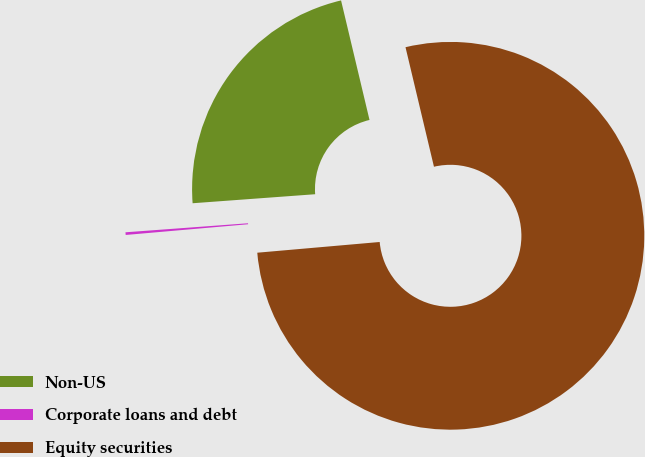<chart> <loc_0><loc_0><loc_500><loc_500><pie_chart><fcel>Non-US<fcel>Corporate loans and debt<fcel>Equity securities<nl><fcel>22.45%<fcel>0.22%<fcel>77.33%<nl></chart> 